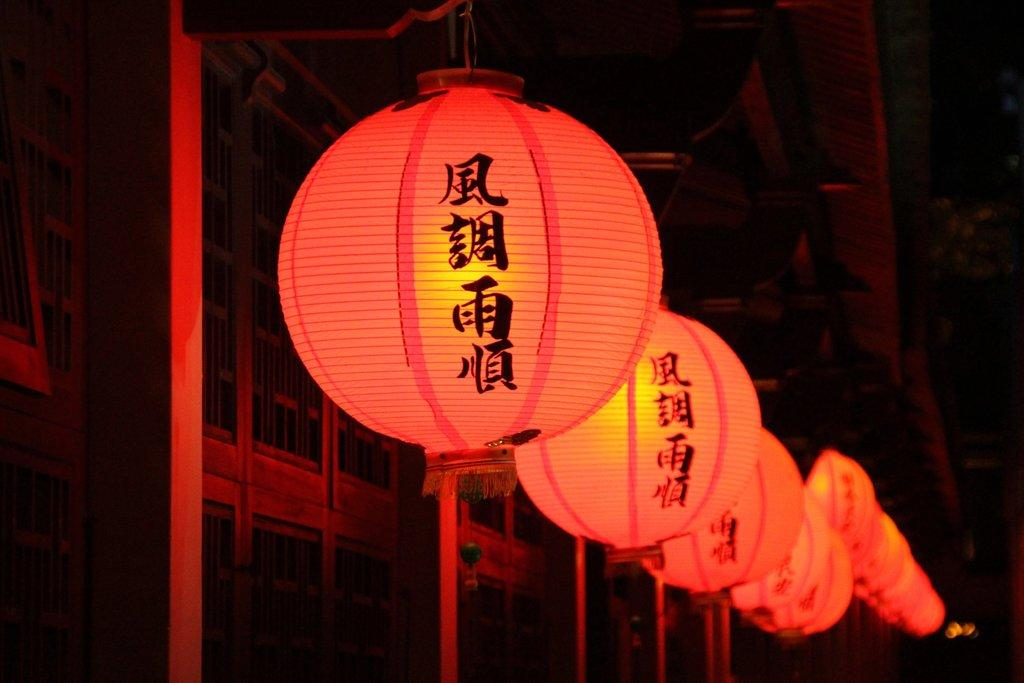What type of decorative objects can be seen in the image? There are paper lanterns in the image. What are the poles at the bottom of the image used for? The purpose of the poles at the bottom of the image is not specified, but they could be supporting the lanterns or serving another function. Is the metal hot to the touch in the image? There is no mention of metal in the image, so it is not possible to determine if it is hot or not. 